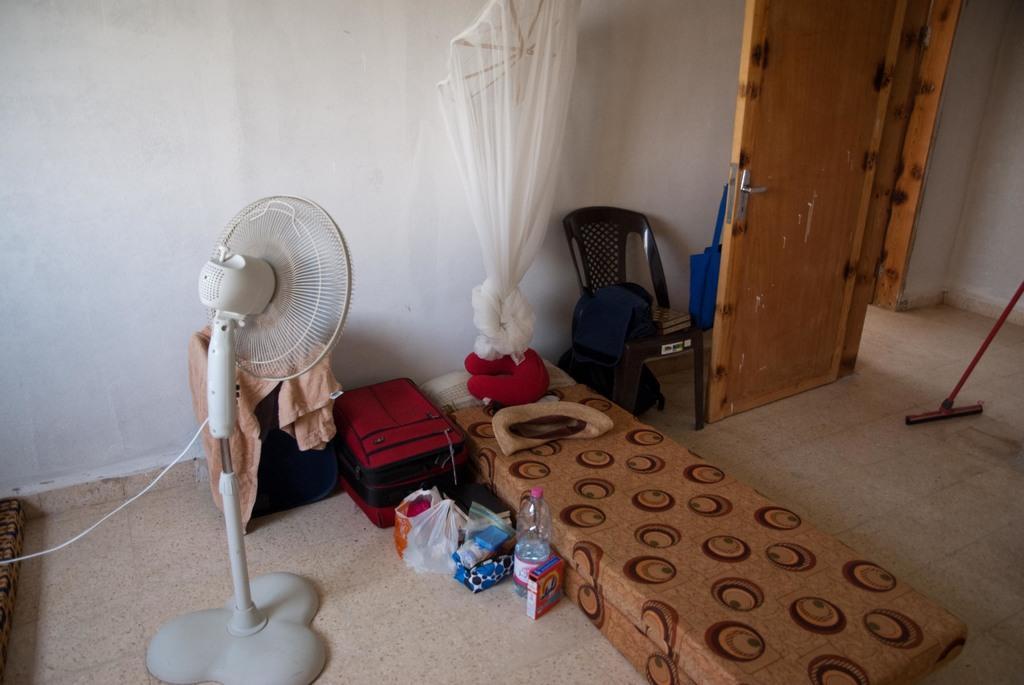Describe this image in one or two sentences. There is a room. There is a net,bed,bottle ,polythene cover,suitcase ,chair and door in a room. 